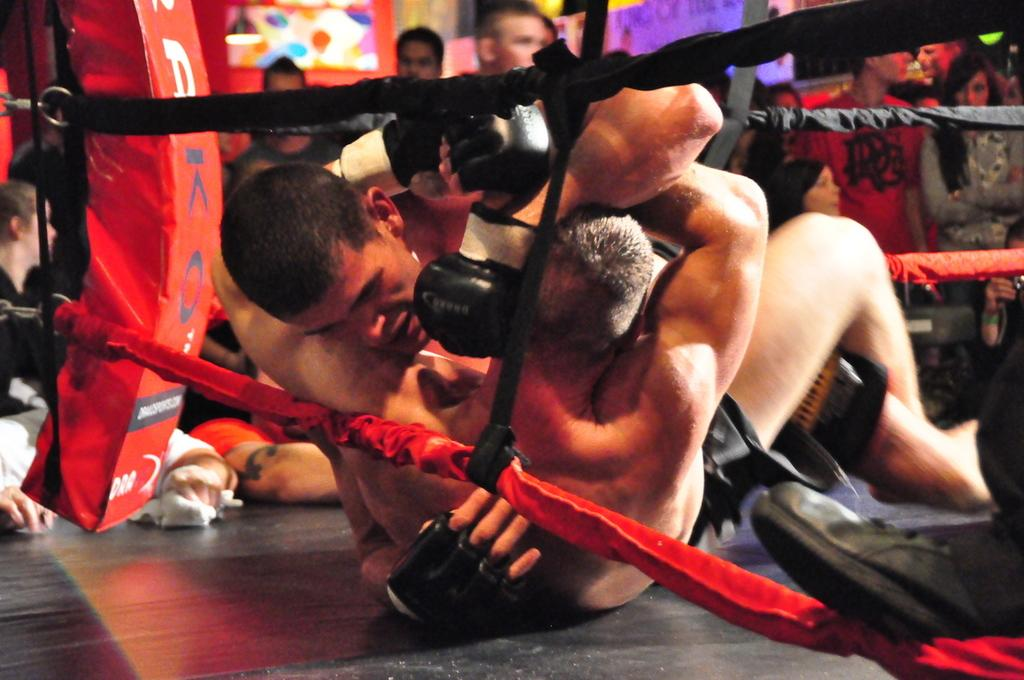How many people are in the image? There is a group of people in the image. What are some of the people in the image doing? Some people are standing, and two people are on a boxing ring. What can be seen in the background of the image? There are lights visible in the background of the image. What type of oatmeal is being served to the sisters in the image? There is no oatmeal or sisters present in the image. How does the cough of the person in the image affect their performance on the boxing ring? There is no mention of a cough or a person's performance in the image. 